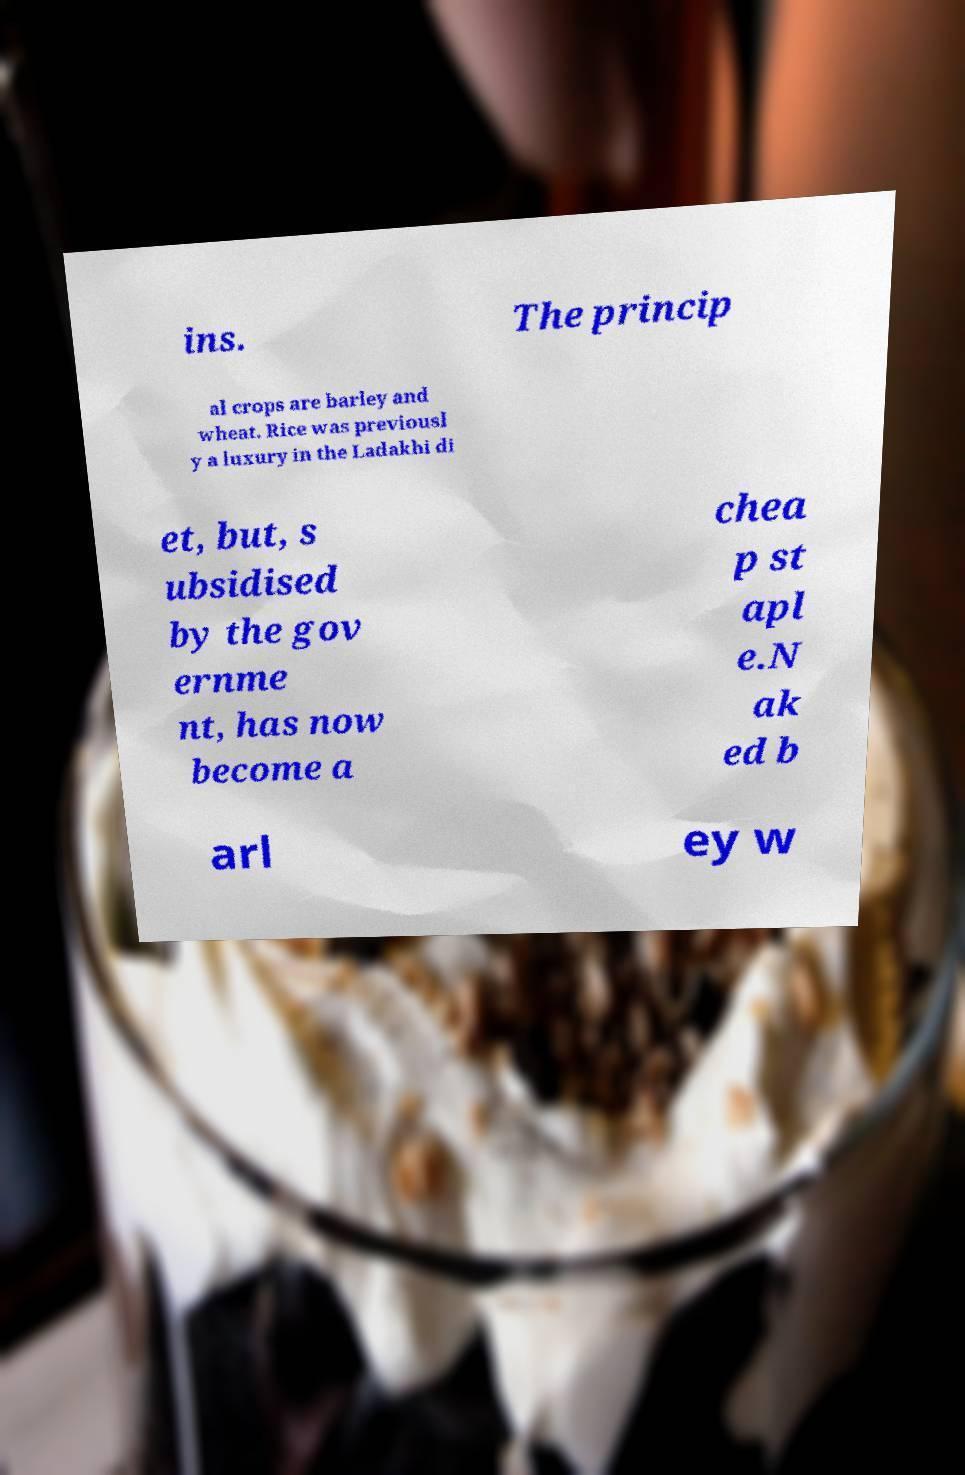Please read and relay the text visible in this image. What does it say? ins. The princip al crops are barley and wheat. Rice was previousl y a luxury in the Ladakhi di et, but, s ubsidised by the gov ernme nt, has now become a chea p st apl e.N ak ed b arl ey w 